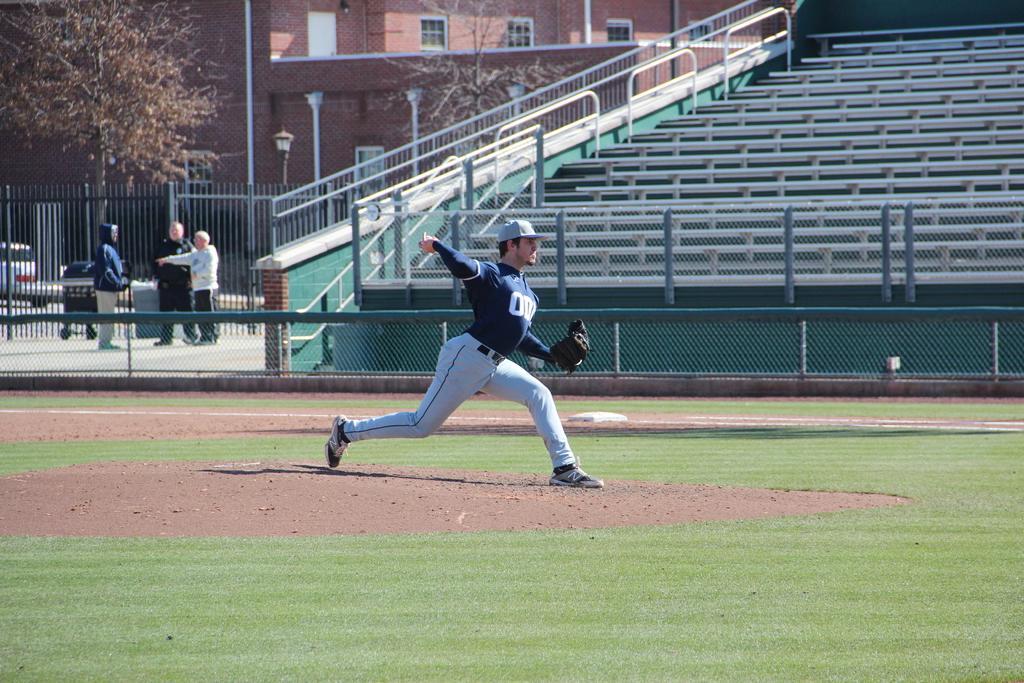How would you summarize this image in a sentence or two? In this picture there is a person wearing blue dress is standing and wearing a glove to one of his hand and there is a fence beside him and there are three persons standing in the left corner and there are few dried trees and a building in the background. 